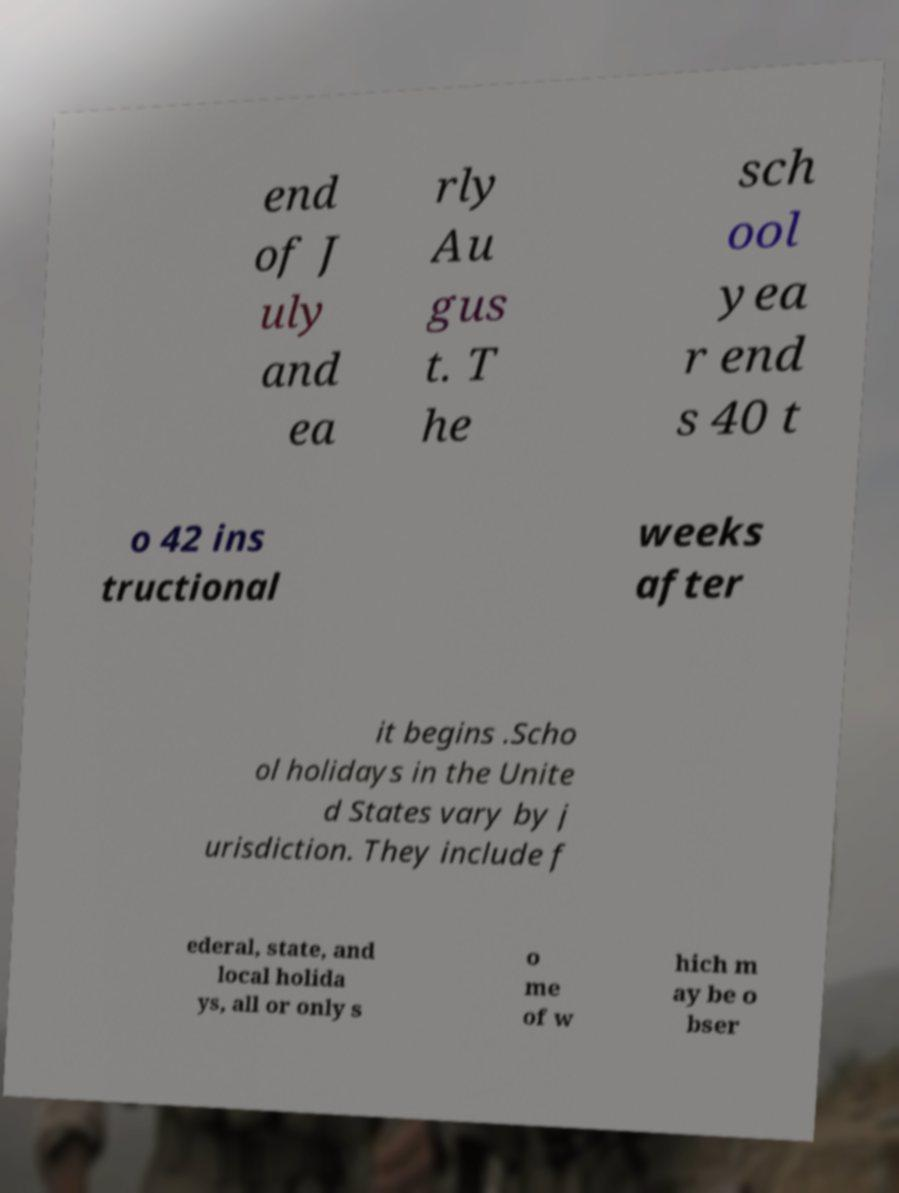Could you assist in decoding the text presented in this image and type it out clearly? end of J uly and ea rly Au gus t. T he sch ool yea r end s 40 t o 42 ins tructional weeks after it begins .Scho ol holidays in the Unite d States vary by j urisdiction. They include f ederal, state, and local holida ys, all or only s o me of w hich m ay be o bser 